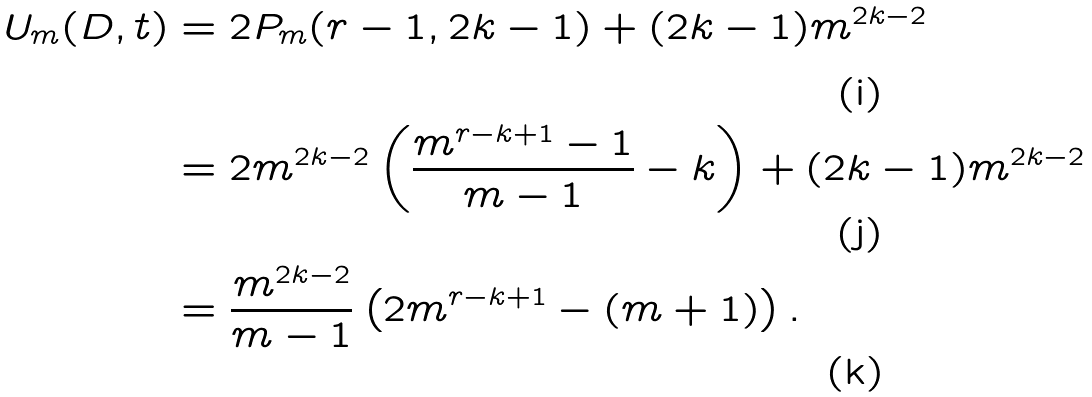<formula> <loc_0><loc_0><loc_500><loc_500>U _ { m } ( D , t ) & = 2 P _ { m } ( r - 1 , 2 k - 1 ) + ( 2 k - 1 ) m ^ { 2 k - 2 } \\ & = 2 m ^ { 2 k - 2 } \left ( \frac { m ^ { r - k + 1 } - 1 } { m - 1 } - k \right ) + ( 2 k - 1 ) m ^ { 2 k - 2 } \\ & = \frac { m ^ { 2 k - 2 } } { m - 1 } \left ( 2 m ^ { r - k + 1 } - ( m + 1 ) \right ) .</formula> 